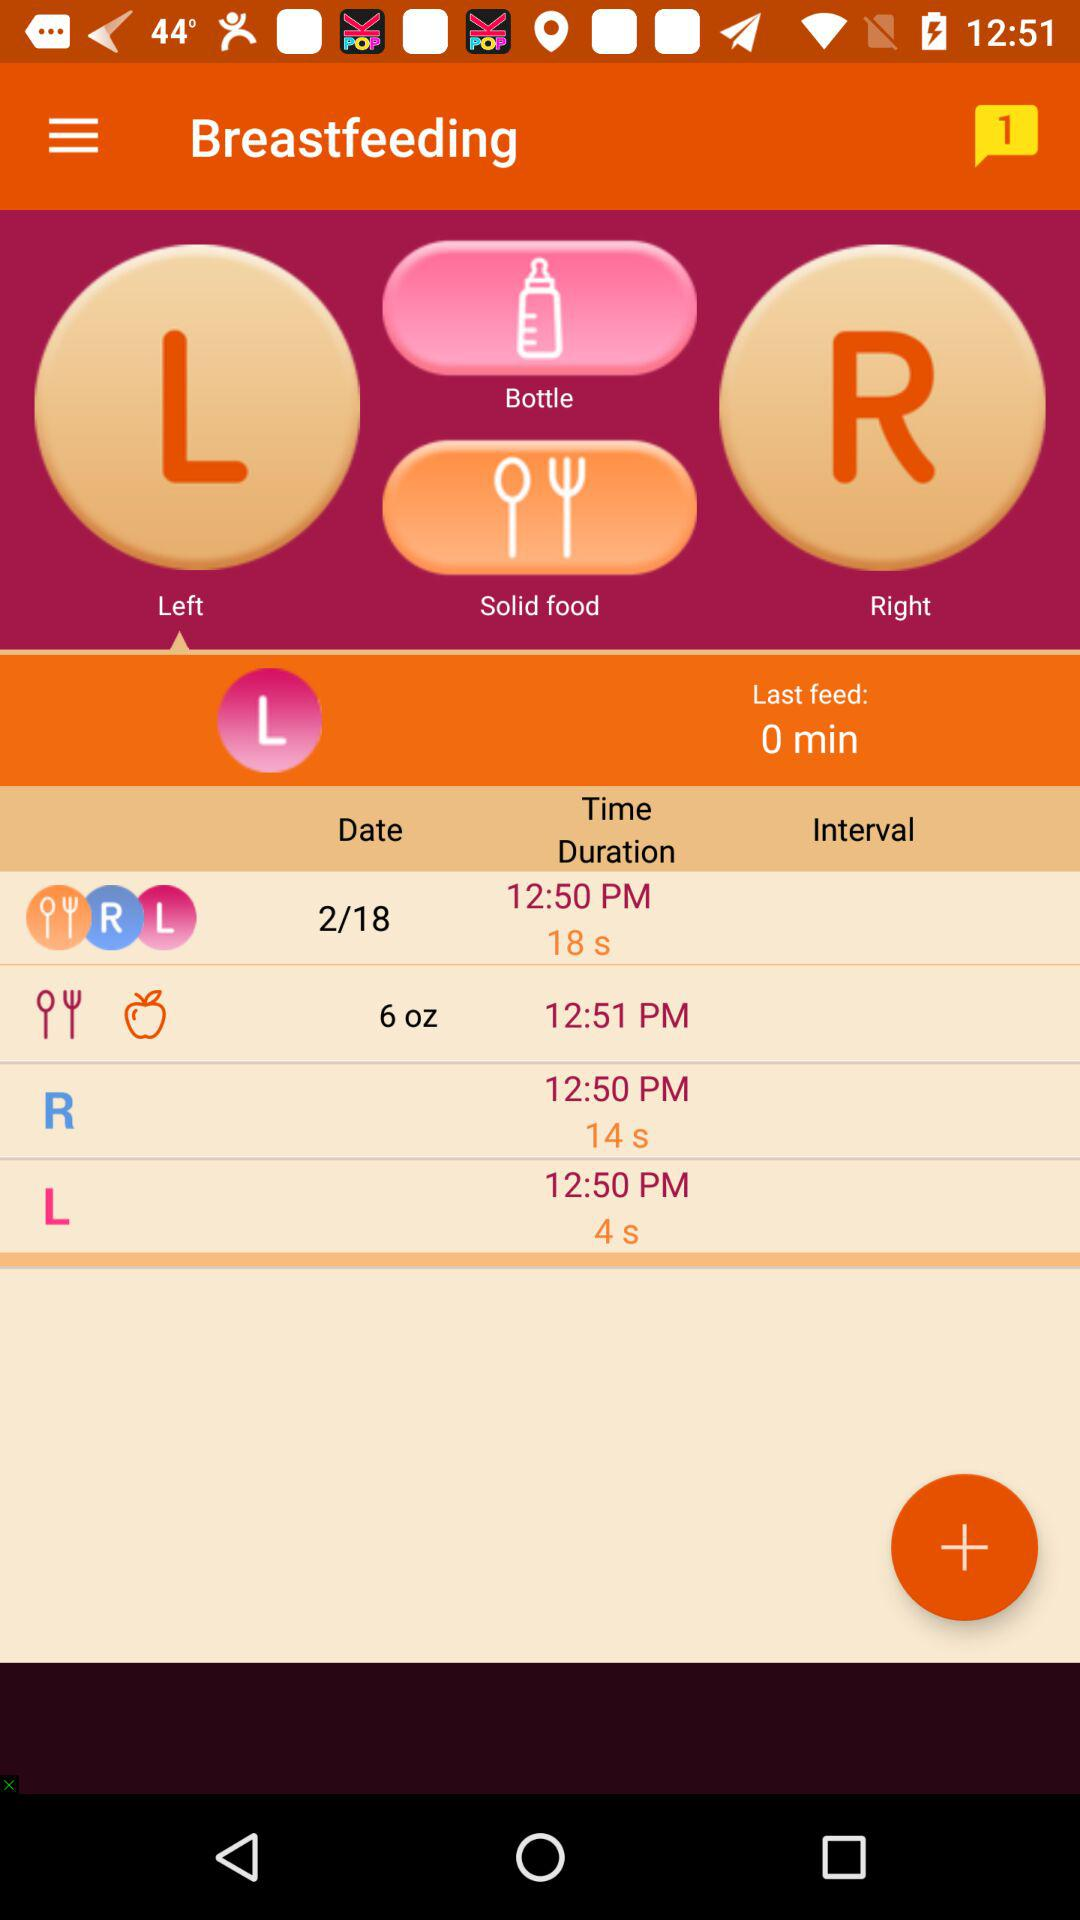What is the time duration of breast feeding at 12:50 PM? The time duration is 18 seconds. 